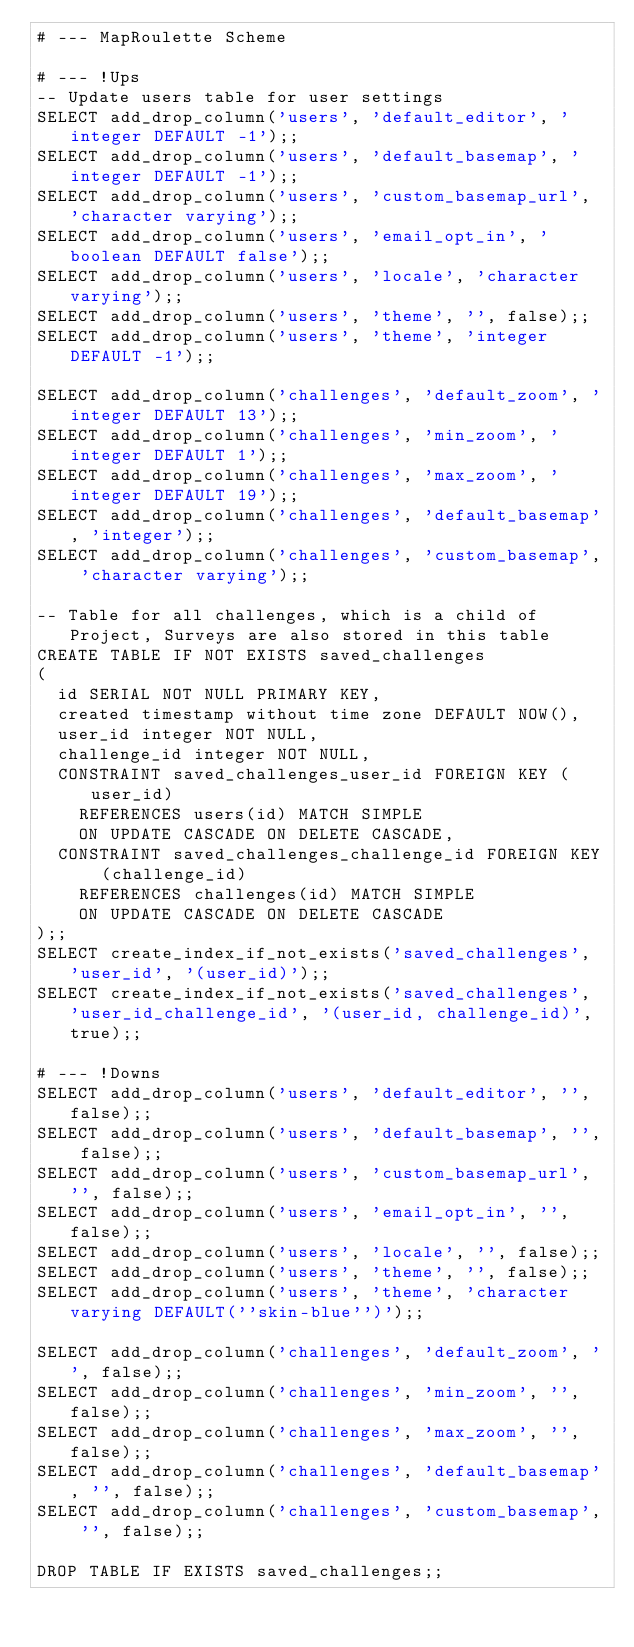Convert code to text. <code><loc_0><loc_0><loc_500><loc_500><_SQL_># --- MapRoulette Scheme

# --- !Ups
-- Update users table for user settings
SELECT add_drop_column('users', 'default_editor', 'integer DEFAULT -1');;
SELECT add_drop_column('users', 'default_basemap', 'integer DEFAULT -1');;
SELECT add_drop_column('users', 'custom_basemap_url', 'character varying');;
SELECT add_drop_column('users', 'email_opt_in', 'boolean DEFAULT false');;
SELECT add_drop_column('users', 'locale', 'character varying');;
SELECT add_drop_column('users', 'theme', '', false);;
SELECT add_drop_column('users', 'theme', 'integer DEFAULT -1');;

SELECT add_drop_column('challenges', 'default_zoom', 'integer DEFAULT 13');;
SELECT add_drop_column('challenges', 'min_zoom', 'integer DEFAULT 1');;
SELECT add_drop_column('challenges', 'max_zoom', 'integer DEFAULT 19');;
SELECT add_drop_column('challenges', 'default_basemap', 'integer');;
SELECT add_drop_column('challenges', 'custom_basemap', 'character varying');;

-- Table for all challenges, which is a child of Project, Surveys are also stored in this table
CREATE TABLE IF NOT EXISTS saved_challenges
(
  id SERIAL NOT NULL PRIMARY KEY,
  created timestamp without time zone DEFAULT NOW(),
  user_id integer NOT NULL,
  challenge_id integer NOT NULL,
  CONSTRAINT saved_challenges_user_id FOREIGN KEY (user_id)
    REFERENCES users(id) MATCH SIMPLE
    ON UPDATE CASCADE ON DELETE CASCADE,
  CONSTRAINT saved_challenges_challenge_id FOREIGN KEY (challenge_id)
    REFERENCES challenges(id) MATCH SIMPLE
    ON UPDATE CASCADE ON DELETE CASCADE
);;
SELECT create_index_if_not_exists('saved_challenges', 'user_id', '(user_id)');;
SELECT create_index_if_not_exists('saved_challenges', 'user_id_challenge_id', '(user_id, challenge_id)', true);;

# --- !Downs
SELECT add_drop_column('users', 'default_editor', '', false);;
SELECT add_drop_column('users', 'default_basemap', '', false);;
SELECT add_drop_column('users', 'custom_basemap_url', '', false);;
SELECT add_drop_column('users', 'email_opt_in', '', false);;
SELECT add_drop_column('users', 'locale', '', false);;
SELECT add_drop_column('users', 'theme', '', false);;
SELECT add_drop_column('users', 'theme', 'character varying DEFAULT(''skin-blue'')');;

SELECT add_drop_column('challenges', 'default_zoom', '', false);;
SELECT add_drop_column('challenges', 'min_zoom', '', false);;
SELECT add_drop_column('challenges', 'max_zoom', '', false);;
SELECT add_drop_column('challenges', 'default_basemap', '', false);;
SELECT add_drop_column('challenges', 'custom_basemap', '', false);;

DROP TABLE IF EXISTS saved_challenges;;
</code> 